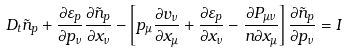<formula> <loc_0><loc_0><loc_500><loc_500>D _ { t } \tilde { n } _ { p } + \frac { \partial \varepsilon _ { p } } { \partial p _ { \nu } } \frac { \partial \tilde { n } _ { p } } { \partial x _ { \nu } } - \left [ p _ { \mu } \frac { \partial v _ { \nu } } { \partial x _ { \mu } } + \frac { \partial \varepsilon _ { p } } { \partial x _ { \nu } } - \frac { \partial P _ { \mu \nu } } { n \partial x _ { \mu } } \right ] \frac { \partial \tilde { n } _ { p } } { \partial p _ { \nu } } = I</formula> 